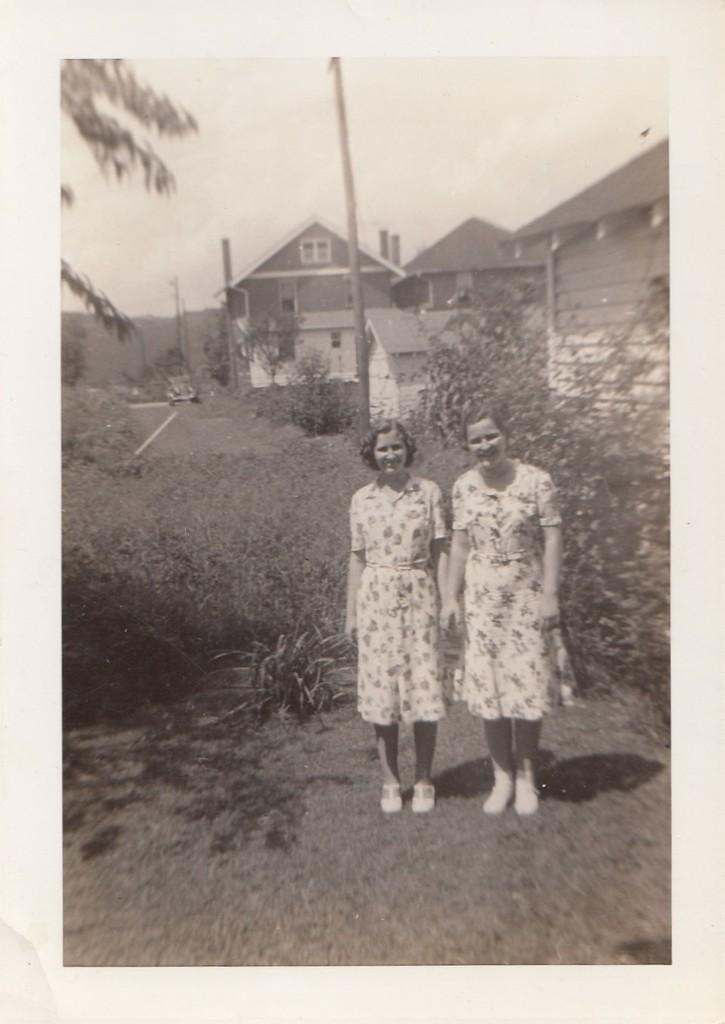How would you summarize this image in a sentence or two? This is an old black and white image. I can see two women standing and smiling. These are the bushes and trees. I can see the houses with the windows. I think these are the poles. 